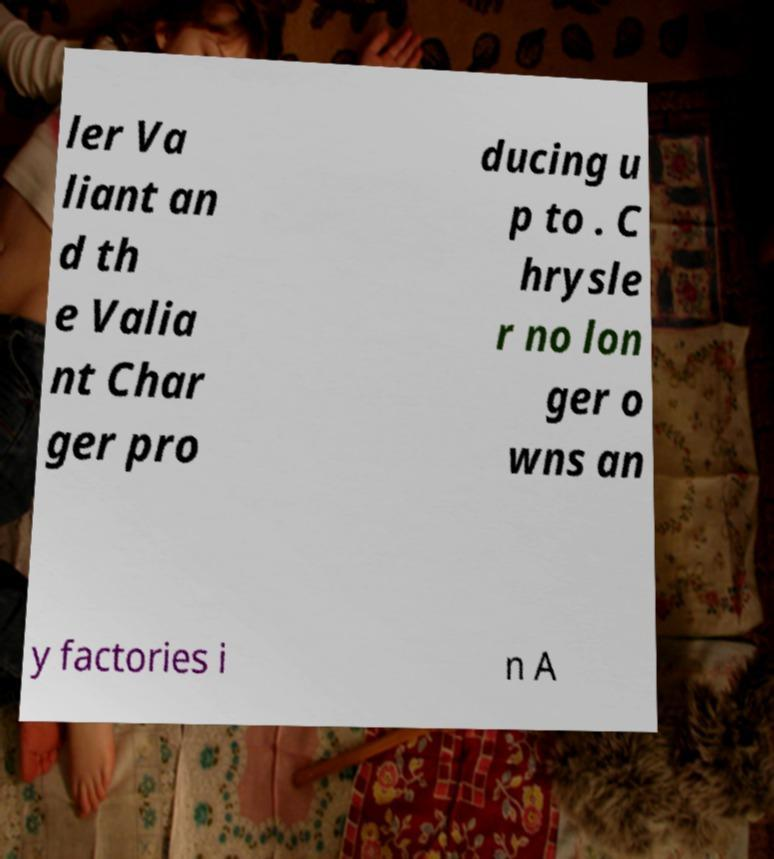Can you read and provide the text displayed in the image?This photo seems to have some interesting text. Can you extract and type it out for me? ler Va liant an d th e Valia nt Char ger pro ducing u p to . C hrysle r no lon ger o wns an y factories i n A 